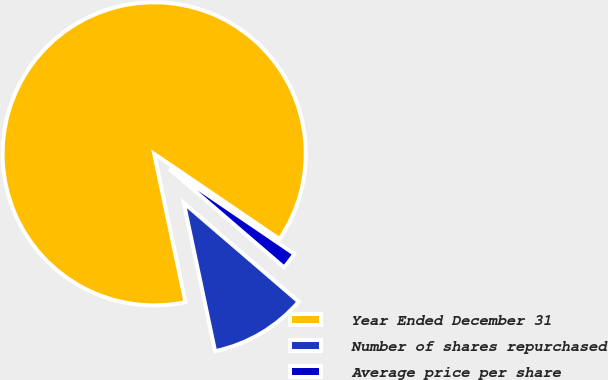<chart> <loc_0><loc_0><loc_500><loc_500><pie_chart><fcel>Year Ended December 31<fcel>Number of shares repurchased<fcel>Average price per share<nl><fcel>87.82%<fcel>10.39%<fcel>1.79%<nl></chart> 